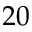<formula> <loc_0><loc_0><loc_500><loc_500>2 0</formula> 